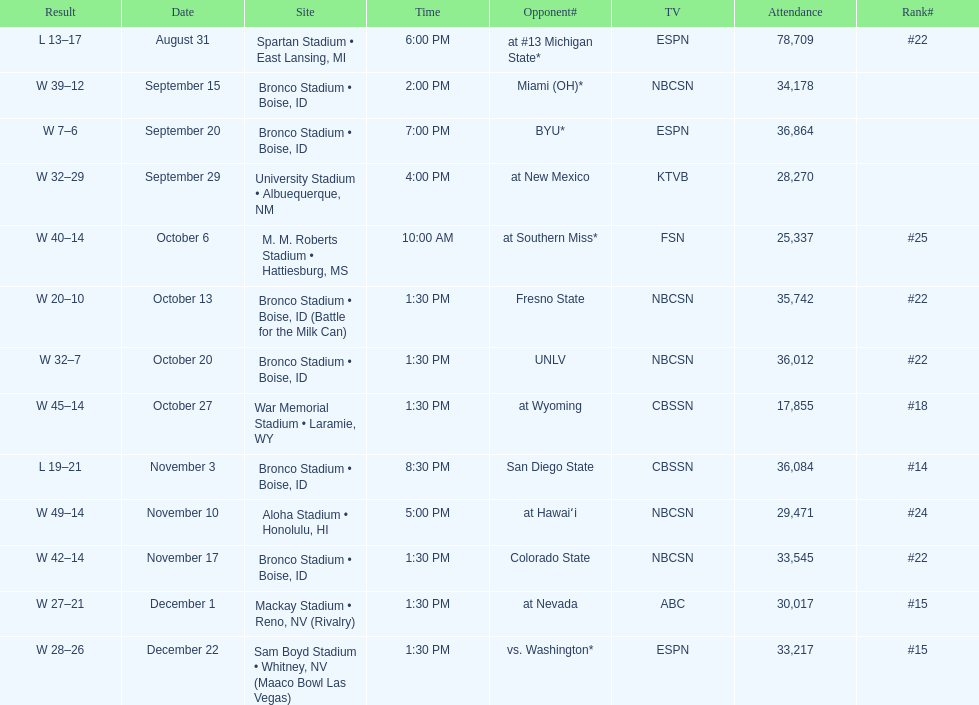What was the most consecutive wins for the team shown in the season? 7. 